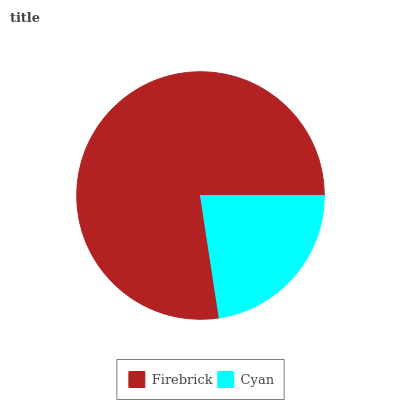Is Cyan the minimum?
Answer yes or no. Yes. Is Firebrick the maximum?
Answer yes or no. Yes. Is Cyan the maximum?
Answer yes or no. No. Is Firebrick greater than Cyan?
Answer yes or no. Yes. Is Cyan less than Firebrick?
Answer yes or no. Yes. Is Cyan greater than Firebrick?
Answer yes or no. No. Is Firebrick less than Cyan?
Answer yes or no. No. Is Firebrick the high median?
Answer yes or no. Yes. Is Cyan the low median?
Answer yes or no. Yes. Is Cyan the high median?
Answer yes or no. No. Is Firebrick the low median?
Answer yes or no. No. 